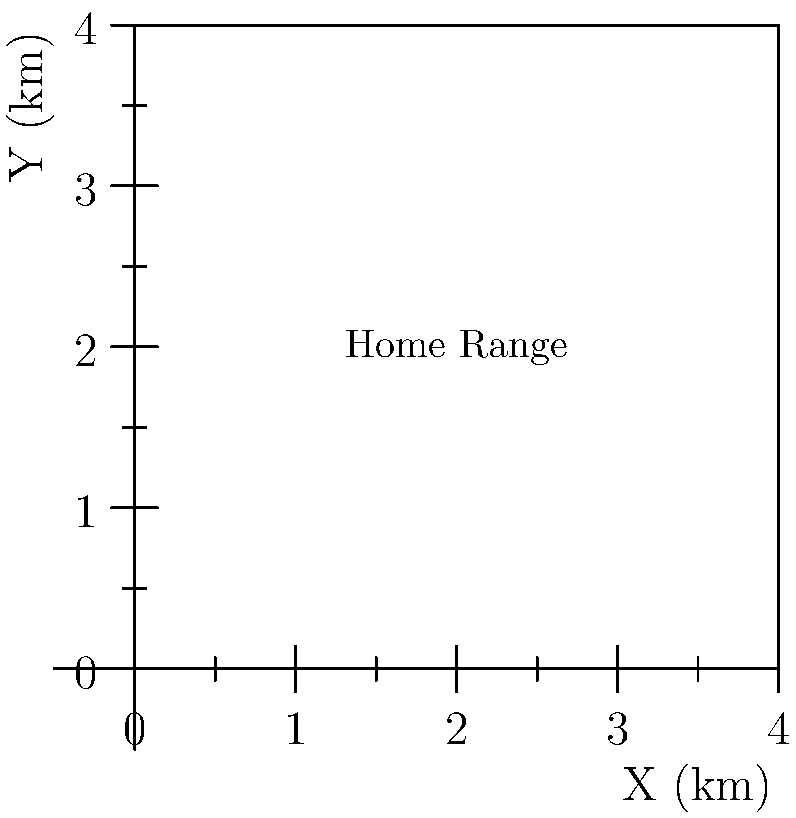A GPS tracking study of a quokka population has produced the data points shown on the map above. Each point represents a location where a quokka was observed. If we assume the home range is rectangular and encompasses all observed points, what is the area of the quokka's home range in square kilometers? To calculate the home range area, we need to follow these steps:

1. Identify the minimum and maximum x-coordinates:
   $x_{min} = 0$, $x_{max} = 4$

2. Identify the minimum and maximum y-coordinates:
   $y_{min} = 0$, $y_{max} = 4$

3. Calculate the width of the rectangle:
   $width = x_{max} - x_{min} = 4 - 0 = 4$ km

4. Calculate the height of the rectangle:
   $height = y_{max} - y_{min} = 4 - 0 = 4$ km

5. Calculate the area of the rectangle:
   $area = width \times height = 4 \times 4 = 16$ sq km

Therefore, the home range of the quokka population is 16 square kilometers.
Answer: 16 sq km 